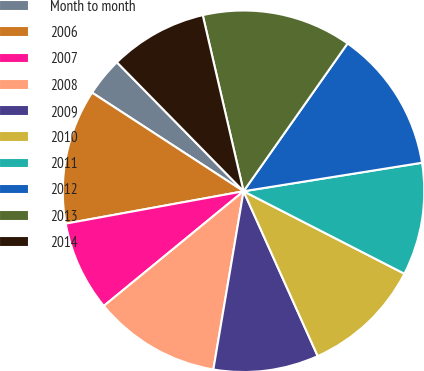Convert chart to OTSL. <chart><loc_0><loc_0><loc_500><loc_500><pie_chart><fcel>Month to month<fcel>2006<fcel>2007<fcel>2008<fcel>2009<fcel>2010<fcel>2011<fcel>2012<fcel>2013<fcel>2014<nl><fcel>3.46%<fcel>12.05%<fcel>8.07%<fcel>11.39%<fcel>9.4%<fcel>10.73%<fcel>10.06%<fcel>12.72%<fcel>13.38%<fcel>8.73%<nl></chart> 